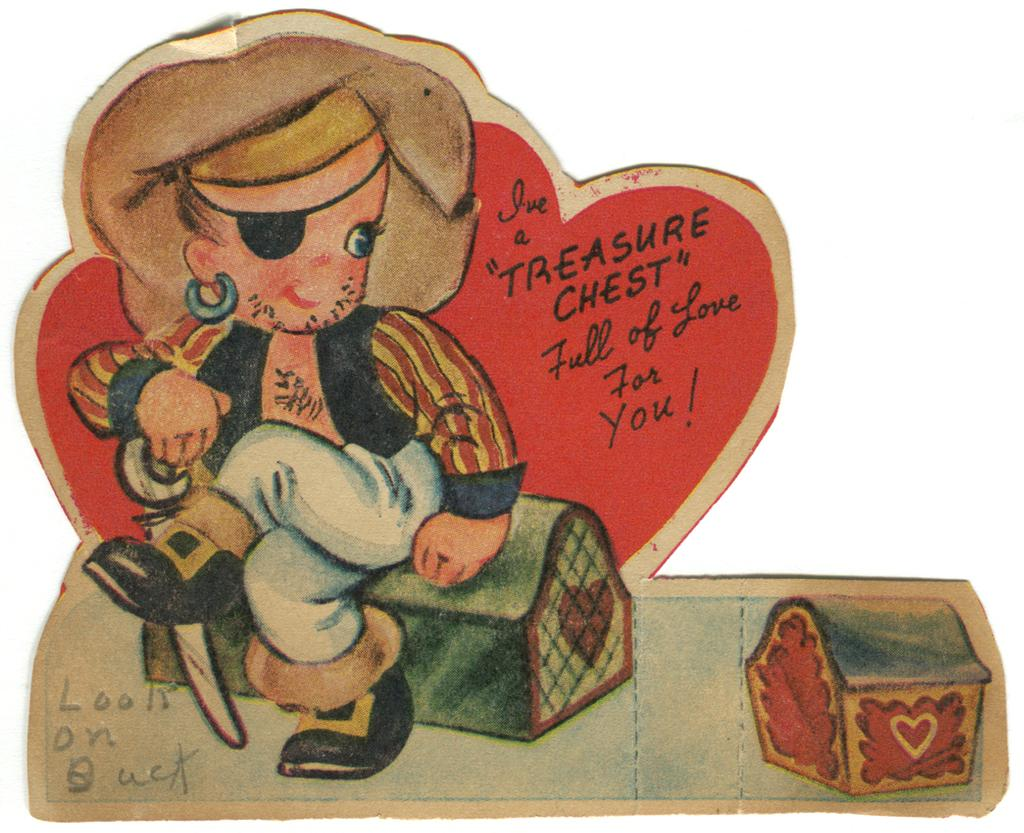Who is the main subject in the image? There is a girl in the image. What is the girl doing in the image? The girl is sitting on a box. Are there any other boxes visible in the image? Yes, there is another box beside the girl. What else can be seen in the image besides the girl and the boxes? There is text on the image. What type of riddle is the girl trying to solve with her toe in the image? There is no riddle or toe present in the image; it features a girl sitting on a box with another box beside her and text on the image. 